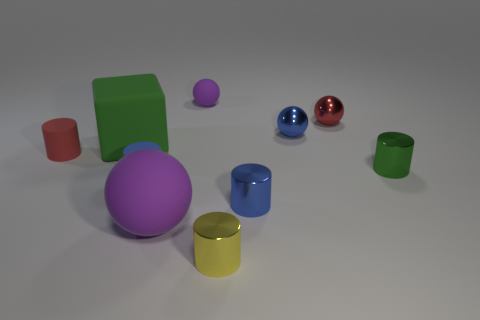What number of small objects are either yellow metal cylinders or green rubber balls? In the image, there is one yellow metal cylinder and two green rubber balls, making the total number of small objects that are either yellow metal cylinders or green rubber balls equal to three. 